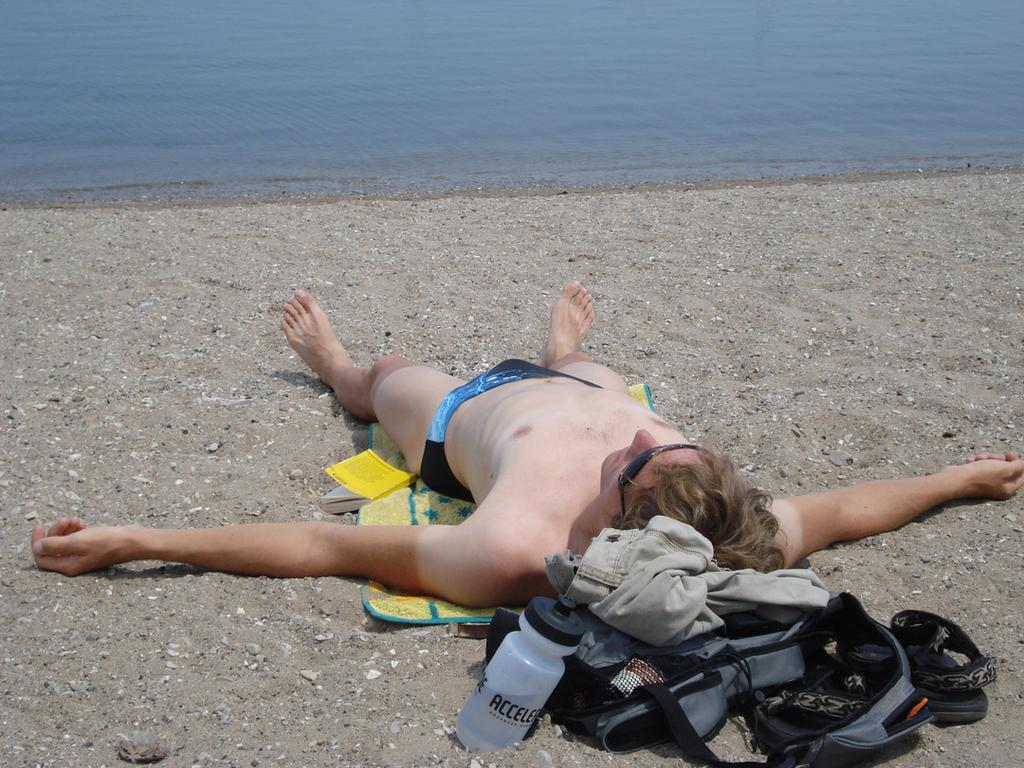What is located in the center of the image? There is a water bottle, a jacket, a backpack, footwear, a book, and a mat in the center of the image. What is the person lying on in the center of the image? The person is lying on a mat in the center of the image. What can be seen in the background of the image? Water is visible in the background of the image. What type of print can be seen on the person's vein in the image? There is no print or vein visible on the person in the image. How does the person wash their hands in the image? There is no indication of hand washing in the image. 